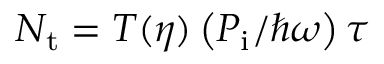<formula> <loc_0><loc_0><loc_500><loc_500>N _ { t } = T ( \eta ) \left ( P _ { i } / \hbar { \omega } \right ) \tau</formula> 